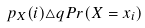<formula> <loc_0><loc_0><loc_500><loc_500>p _ { X } ( i ) \triangle q P r ( X = x _ { i } )</formula> 